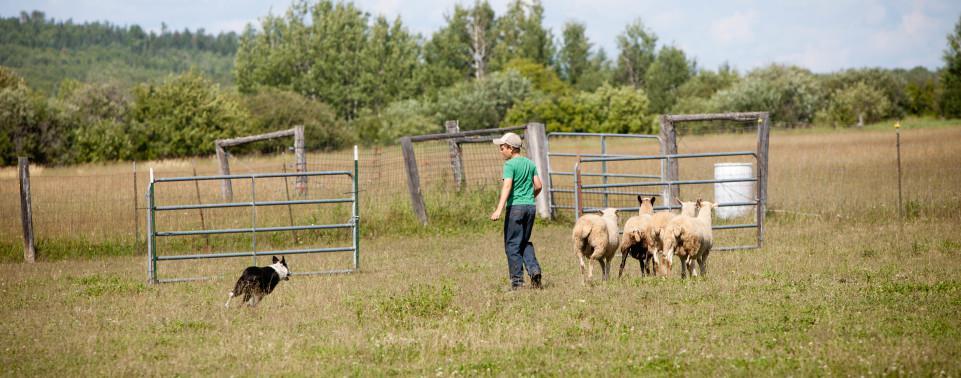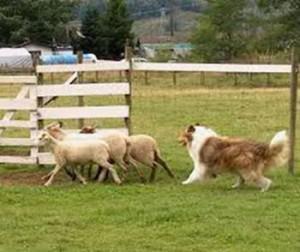The first image is the image on the left, the second image is the image on the right. Given the left and right images, does the statement "The human in one of the images is wearing a baseball cap." hold true? Answer yes or no. Yes. 